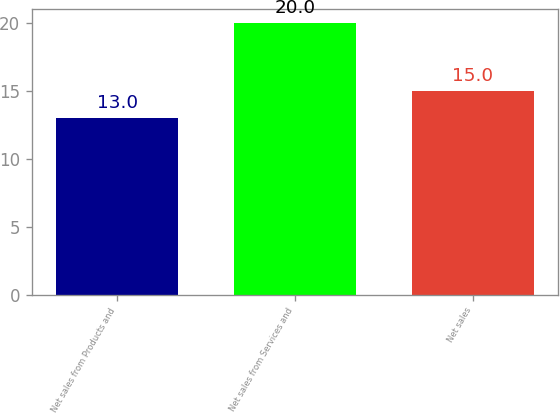Convert chart to OTSL. <chart><loc_0><loc_0><loc_500><loc_500><bar_chart><fcel>Net sales from Products and<fcel>Net sales from Services and<fcel>Net sales<nl><fcel>13<fcel>20<fcel>15<nl></chart> 